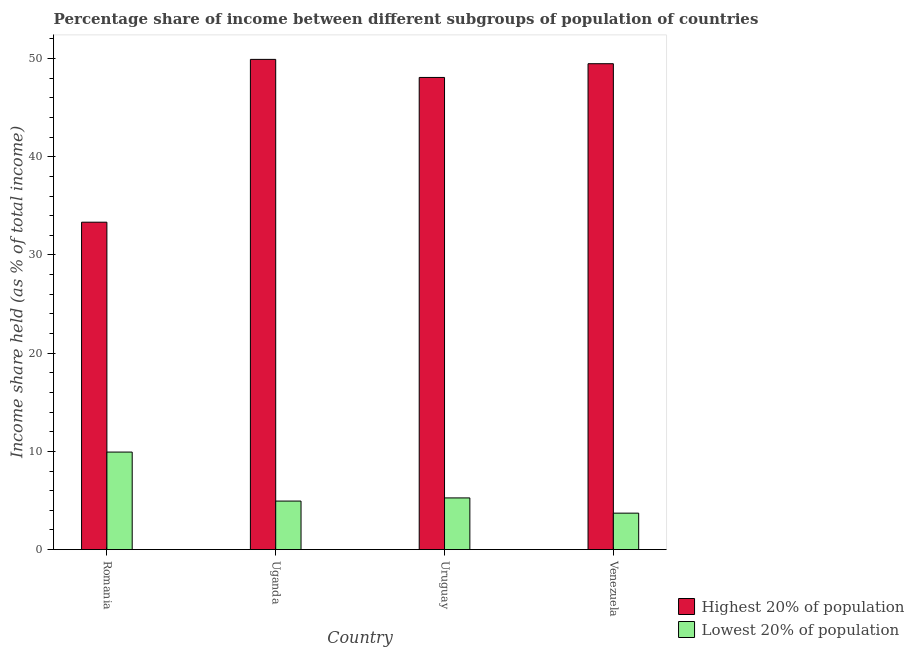How many different coloured bars are there?
Your answer should be compact. 2. Are the number of bars per tick equal to the number of legend labels?
Provide a short and direct response. Yes. How many bars are there on the 2nd tick from the left?
Your answer should be compact. 2. How many bars are there on the 4th tick from the right?
Make the answer very short. 2. What is the label of the 1st group of bars from the left?
Ensure brevity in your answer.  Romania. What is the income share held by lowest 20% of the population in Venezuela?
Provide a succinct answer. 3.71. Across all countries, what is the maximum income share held by lowest 20% of the population?
Your answer should be very brief. 9.93. Across all countries, what is the minimum income share held by lowest 20% of the population?
Offer a very short reply. 3.71. In which country was the income share held by highest 20% of the population maximum?
Your response must be concise. Uganda. In which country was the income share held by highest 20% of the population minimum?
Your answer should be very brief. Romania. What is the total income share held by lowest 20% of the population in the graph?
Provide a short and direct response. 23.84. What is the difference between the income share held by highest 20% of the population in Romania and that in Uganda?
Make the answer very short. -16.58. What is the difference between the income share held by lowest 20% of the population in Romania and the income share held by highest 20% of the population in Uruguay?
Your answer should be very brief. -38.15. What is the average income share held by highest 20% of the population per country?
Keep it short and to the point. 45.2. What is the difference between the income share held by lowest 20% of the population and income share held by highest 20% of the population in Romania?
Provide a succinct answer. -23.41. In how many countries, is the income share held by highest 20% of the population greater than 34 %?
Keep it short and to the point. 3. What is the ratio of the income share held by highest 20% of the population in Uganda to that in Venezuela?
Offer a terse response. 1.01. Is the income share held by highest 20% of the population in Romania less than that in Venezuela?
Provide a short and direct response. Yes. What is the difference between the highest and the second highest income share held by lowest 20% of the population?
Provide a succinct answer. 4.67. What is the difference between the highest and the lowest income share held by highest 20% of the population?
Offer a very short reply. 16.58. In how many countries, is the income share held by lowest 20% of the population greater than the average income share held by lowest 20% of the population taken over all countries?
Your response must be concise. 1. Is the sum of the income share held by highest 20% of the population in Uganda and Uruguay greater than the maximum income share held by lowest 20% of the population across all countries?
Make the answer very short. Yes. What does the 1st bar from the left in Romania represents?
Provide a short and direct response. Highest 20% of population. What does the 2nd bar from the right in Venezuela represents?
Make the answer very short. Highest 20% of population. How many bars are there?
Offer a terse response. 8. Are all the bars in the graph horizontal?
Keep it short and to the point. No. Where does the legend appear in the graph?
Keep it short and to the point. Bottom right. How are the legend labels stacked?
Provide a succinct answer. Vertical. What is the title of the graph?
Give a very brief answer. Percentage share of income between different subgroups of population of countries. Does "Primary income" appear as one of the legend labels in the graph?
Offer a terse response. No. What is the label or title of the Y-axis?
Provide a succinct answer. Income share held (as % of total income). What is the Income share held (as % of total income) in Highest 20% of population in Romania?
Offer a very short reply. 33.34. What is the Income share held (as % of total income) in Lowest 20% of population in Romania?
Provide a short and direct response. 9.93. What is the Income share held (as % of total income) of Highest 20% of population in Uganda?
Your answer should be compact. 49.92. What is the Income share held (as % of total income) in Lowest 20% of population in Uganda?
Provide a short and direct response. 4.94. What is the Income share held (as % of total income) of Highest 20% of population in Uruguay?
Offer a very short reply. 48.08. What is the Income share held (as % of total income) of Lowest 20% of population in Uruguay?
Give a very brief answer. 5.26. What is the Income share held (as % of total income) in Highest 20% of population in Venezuela?
Your response must be concise. 49.48. What is the Income share held (as % of total income) of Lowest 20% of population in Venezuela?
Your response must be concise. 3.71. Across all countries, what is the maximum Income share held (as % of total income) in Highest 20% of population?
Give a very brief answer. 49.92. Across all countries, what is the maximum Income share held (as % of total income) of Lowest 20% of population?
Your answer should be compact. 9.93. Across all countries, what is the minimum Income share held (as % of total income) in Highest 20% of population?
Ensure brevity in your answer.  33.34. Across all countries, what is the minimum Income share held (as % of total income) in Lowest 20% of population?
Provide a succinct answer. 3.71. What is the total Income share held (as % of total income) in Highest 20% of population in the graph?
Offer a very short reply. 180.82. What is the total Income share held (as % of total income) in Lowest 20% of population in the graph?
Provide a succinct answer. 23.84. What is the difference between the Income share held (as % of total income) of Highest 20% of population in Romania and that in Uganda?
Keep it short and to the point. -16.58. What is the difference between the Income share held (as % of total income) in Lowest 20% of population in Romania and that in Uganda?
Your response must be concise. 4.99. What is the difference between the Income share held (as % of total income) in Highest 20% of population in Romania and that in Uruguay?
Your answer should be compact. -14.74. What is the difference between the Income share held (as % of total income) of Lowest 20% of population in Romania and that in Uruguay?
Ensure brevity in your answer.  4.67. What is the difference between the Income share held (as % of total income) of Highest 20% of population in Romania and that in Venezuela?
Ensure brevity in your answer.  -16.14. What is the difference between the Income share held (as % of total income) of Lowest 20% of population in Romania and that in Venezuela?
Make the answer very short. 6.22. What is the difference between the Income share held (as % of total income) in Highest 20% of population in Uganda and that in Uruguay?
Your answer should be very brief. 1.84. What is the difference between the Income share held (as % of total income) in Lowest 20% of population in Uganda and that in Uruguay?
Ensure brevity in your answer.  -0.32. What is the difference between the Income share held (as % of total income) in Highest 20% of population in Uganda and that in Venezuela?
Your answer should be compact. 0.44. What is the difference between the Income share held (as % of total income) in Lowest 20% of population in Uganda and that in Venezuela?
Provide a succinct answer. 1.23. What is the difference between the Income share held (as % of total income) in Highest 20% of population in Uruguay and that in Venezuela?
Ensure brevity in your answer.  -1.4. What is the difference between the Income share held (as % of total income) of Lowest 20% of population in Uruguay and that in Venezuela?
Your answer should be compact. 1.55. What is the difference between the Income share held (as % of total income) of Highest 20% of population in Romania and the Income share held (as % of total income) of Lowest 20% of population in Uganda?
Your answer should be compact. 28.4. What is the difference between the Income share held (as % of total income) in Highest 20% of population in Romania and the Income share held (as % of total income) in Lowest 20% of population in Uruguay?
Offer a terse response. 28.08. What is the difference between the Income share held (as % of total income) in Highest 20% of population in Romania and the Income share held (as % of total income) in Lowest 20% of population in Venezuela?
Make the answer very short. 29.63. What is the difference between the Income share held (as % of total income) in Highest 20% of population in Uganda and the Income share held (as % of total income) in Lowest 20% of population in Uruguay?
Your response must be concise. 44.66. What is the difference between the Income share held (as % of total income) of Highest 20% of population in Uganda and the Income share held (as % of total income) of Lowest 20% of population in Venezuela?
Make the answer very short. 46.21. What is the difference between the Income share held (as % of total income) in Highest 20% of population in Uruguay and the Income share held (as % of total income) in Lowest 20% of population in Venezuela?
Make the answer very short. 44.37. What is the average Income share held (as % of total income) of Highest 20% of population per country?
Your response must be concise. 45.2. What is the average Income share held (as % of total income) in Lowest 20% of population per country?
Your answer should be compact. 5.96. What is the difference between the Income share held (as % of total income) in Highest 20% of population and Income share held (as % of total income) in Lowest 20% of population in Romania?
Ensure brevity in your answer.  23.41. What is the difference between the Income share held (as % of total income) of Highest 20% of population and Income share held (as % of total income) of Lowest 20% of population in Uganda?
Offer a terse response. 44.98. What is the difference between the Income share held (as % of total income) in Highest 20% of population and Income share held (as % of total income) in Lowest 20% of population in Uruguay?
Keep it short and to the point. 42.82. What is the difference between the Income share held (as % of total income) in Highest 20% of population and Income share held (as % of total income) in Lowest 20% of population in Venezuela?
Offer a terse response. 45.77. What is the ratio of the Income share held (as % of total income) of Highest 20% of population in Romania to that in Uganda?
Your answer should be very brief. 0.67. What is the ratio of the Income share held (as % of total income) in Lowest 20% of population in Romania to that in Uganda?
Make the answer very short. 2.01. What is the ratio of the Income share held (as % of total income) in Highest 20% of population in Romania to that in Uruguay?
Ensure brevity in your answer.  0.69. What is the ratio of the Income share held (as % of total income) in Lowest 20% of population in Romania to that in Uruguay?
Provide a short and direct response. 1.89. What is the ratio of the Income share held (as % of total income) in Highest 20% of population in Romania to that in Venezuela?
Offer a terse response. 0.67. What is the ratio of the Income share held (as % of total income) of Lowest 20% of population in Romania to that in Venezuela?
Your answer should be very brief. 2.68. What is the ratio of the Income share held (as % of total income) of Highest 20% of population in Uganda to that in Uruguay?
Give a very brief answer. 1.04. What is the ratio of the Income share held (as % of total income) in Lowest 20% of population in Uganda to that in Uruguay?
Give a very brief answer. 0.94. What is the ratio of the Income share held (as % of total income) of Highest 20% of population in Uganda to that in Venezuela?
Provide a short and direct response. 1.01. What is the ratio of the Income share held (as % of total income) in Lowest 20% of population in Uganda to that in Venezuela?
Make the answer very short. 1.33. What is the ratio of the Income share held (as % of total income) of Highest 20% of population in Uruguay to that in Venezuela?
Provide a succinct answer. 0.97. What is the ratio of the Income share held (as % of total income) in Lowest 20% of population in Uruguay to that in Venezuela?
Make the answer very short. 1.42. What is the difference between the highest and the second highest Income share held (as % of total income) of Highest 20% of population?
Your answer should be compact. 0.44. What is the difference between the highest and the second highest Income share held (as % of total income) of Lowest 20% of population?
Your answer should be compact. 4.67. What is the difference between the highest and the lowest Income share held (as % of total income) of Highest 20% of population?
Your answer should be very brief. 16.58. What is the difference between the highest and the lowest Income share held (as % of total income) in Lowest 20% of population?
Ensure brevity in your answer.  6.22. 